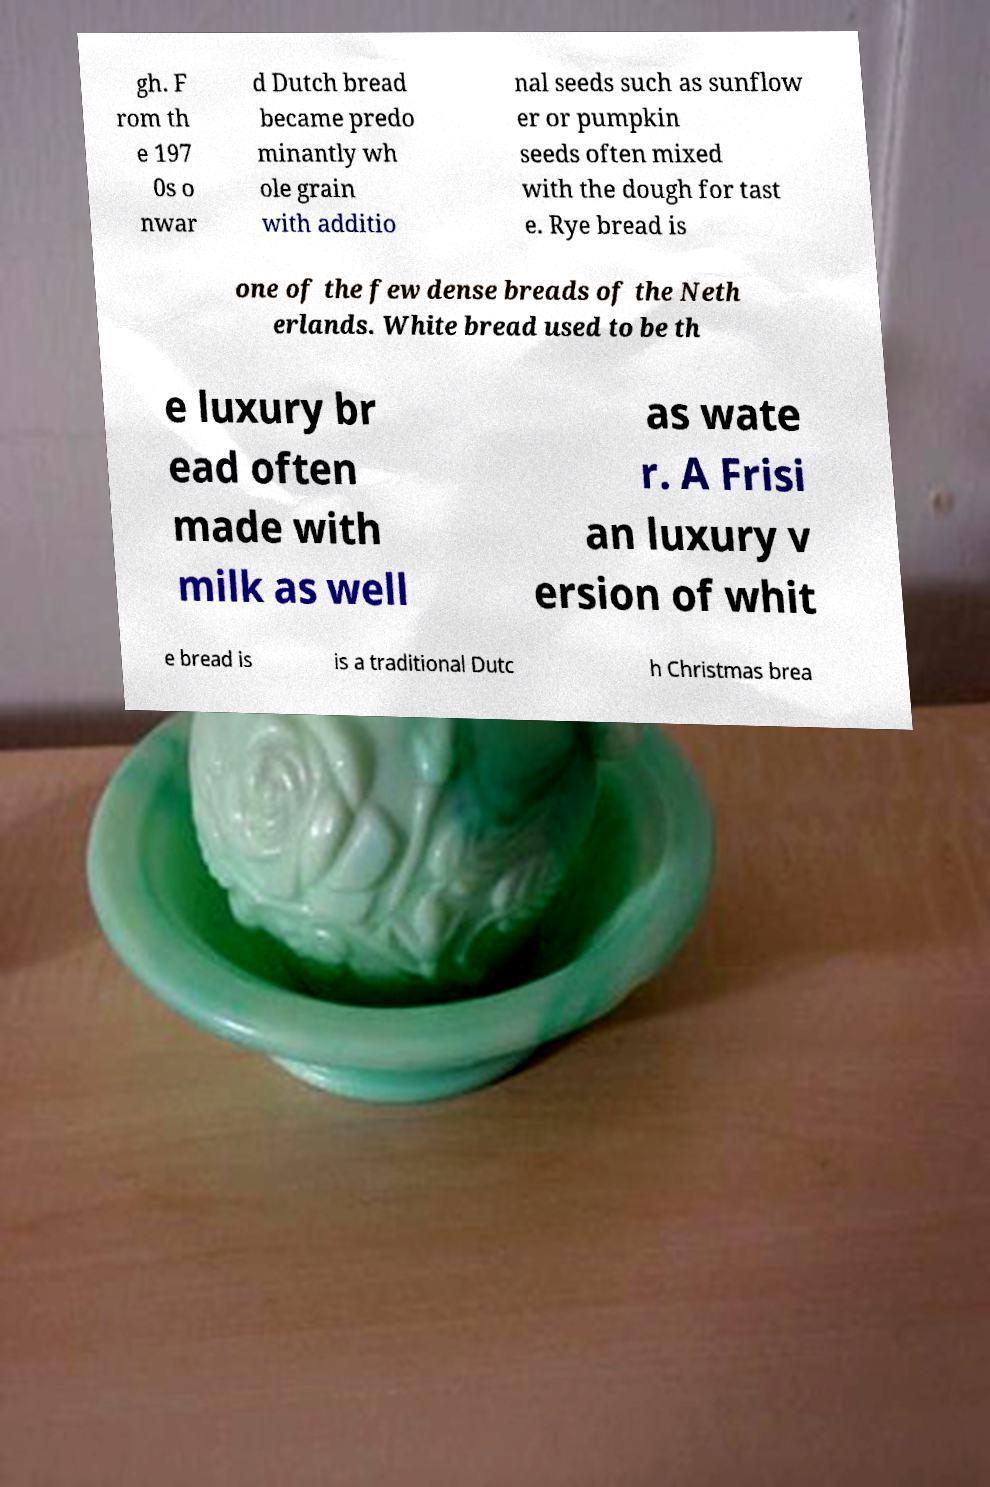Can you read and provide the text displayed in the image?This photo seems to have some interesting text. Can you extract and type it out for me? gh. F rom th e 197 0s o nwar d Dutch bread became predo minantly wh ole grain with additio nal seeds such as sunflow er or pumpkin seeds often mixed with the dough for tast e. Rye bread is one of the few dense breads of the Neth erlands. White bread used to be th e luxury br ead often made with milk as well as wate r. A Frisi an luxury v ersion of whit e bread is is a traditional Dutc h Christmas brea 